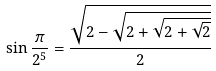Convert formula to latex. <formula><loc_0><loc_0><loc_500><loc_500>\sin { \frac { \pi } { 2 ^ { 5 } } } = { \frac { \sqrt { 2 - { \sqrt { 2 + { \sqrt { 2 + { \sqrt { 2 } } } } } } } } { 2 } }</formula> 